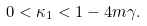<formula> <loc_0><loc_0><loc_500><loc_500>0 < \kappa _ { 1 } < 1 - 4 m \gamma .</formula> 